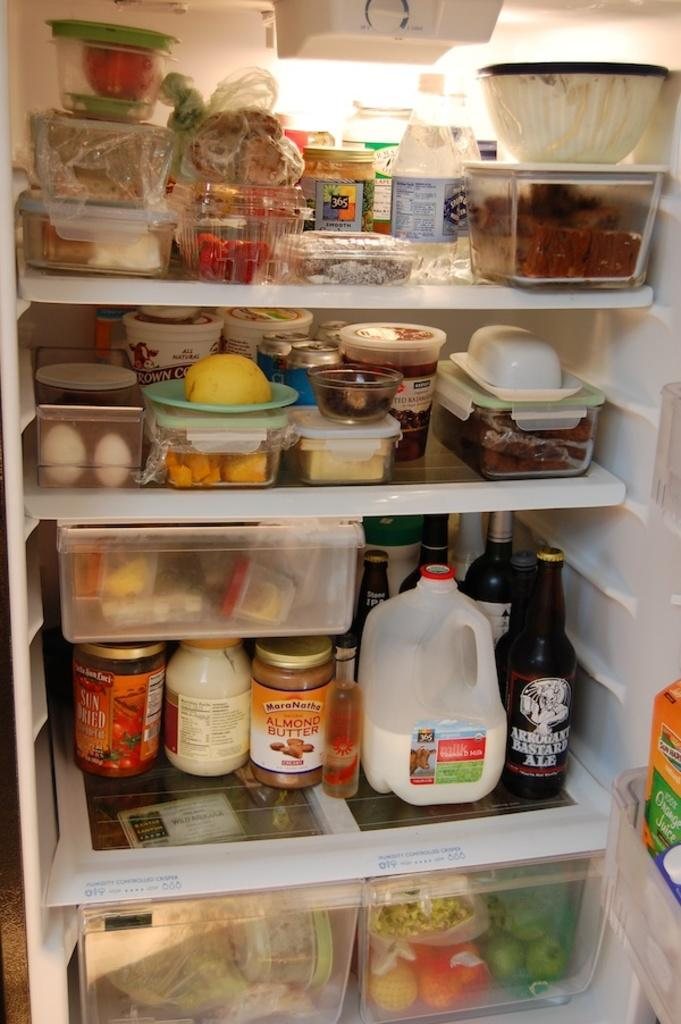<image>
Relay a brief, clear account of the picture shown. Cluttered inside of a fridge shows an ale next to the milk. 